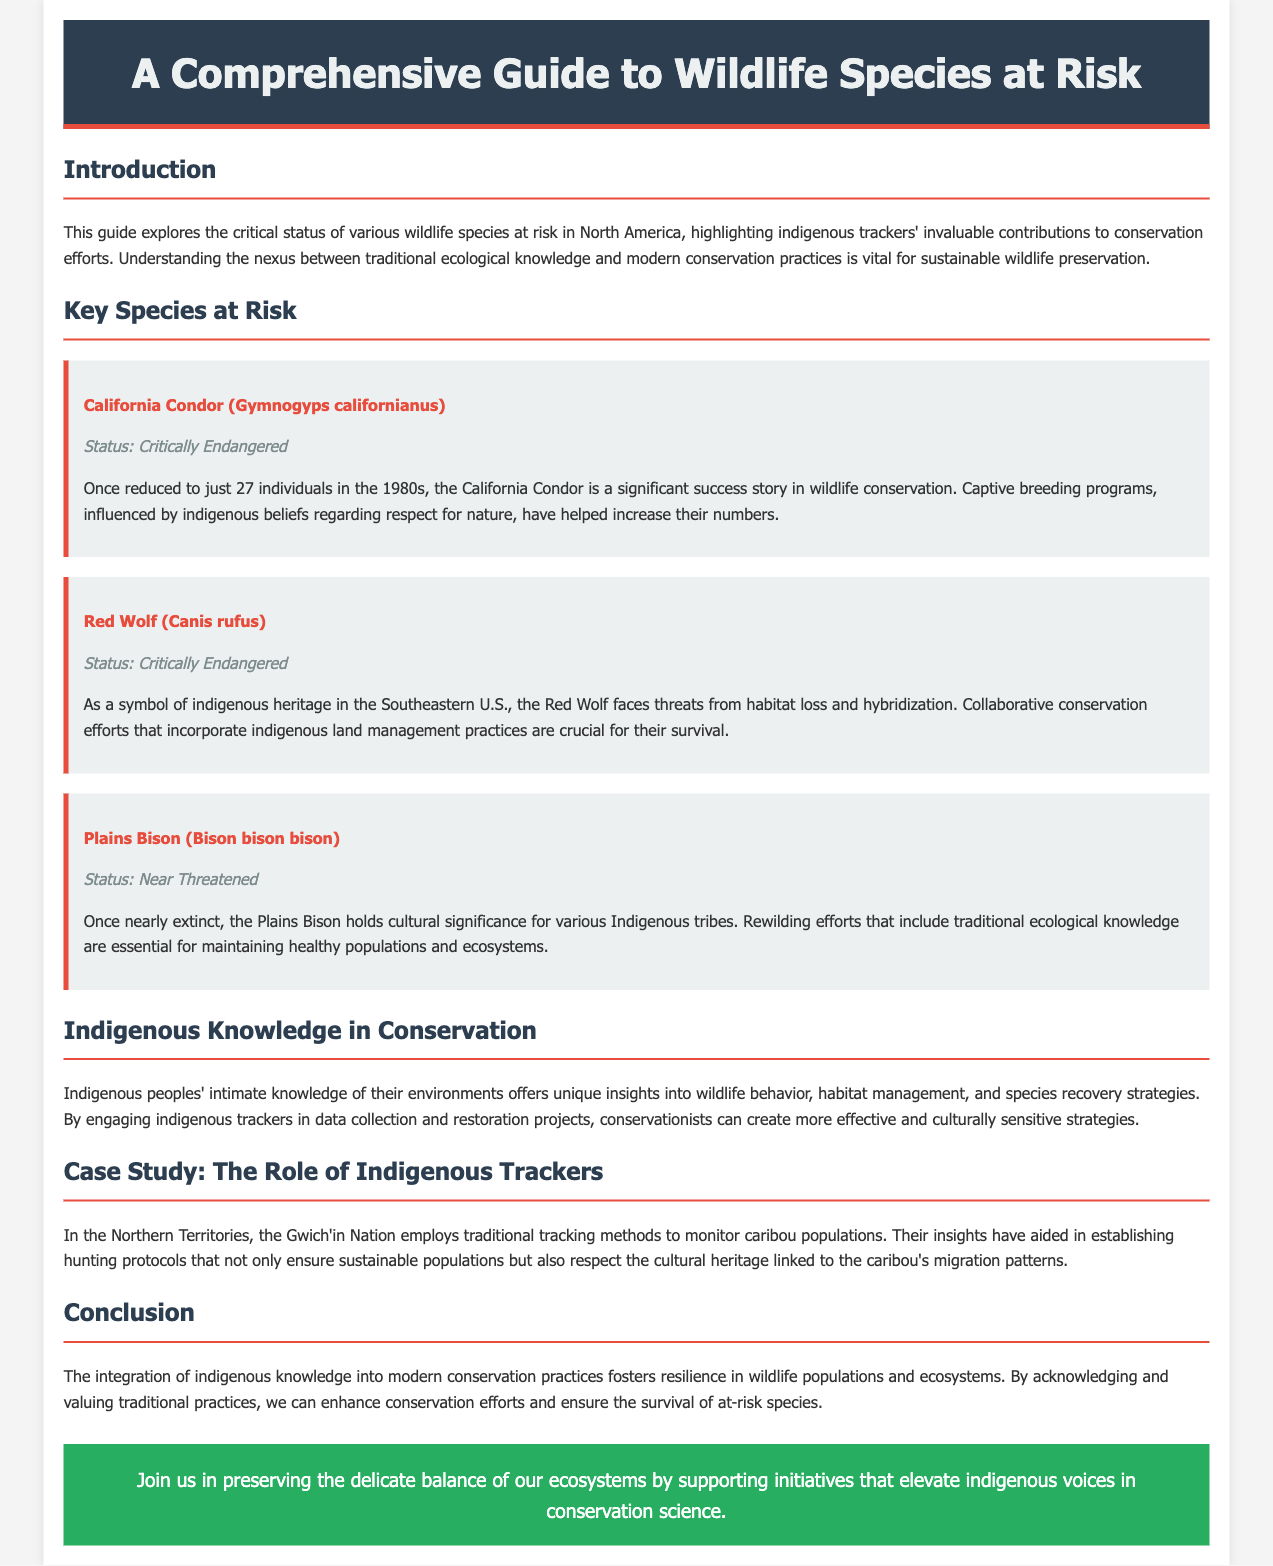What is the title of the document? The title is presented prominently at the top of the document in the header section.
Answer: A Comprehensive Guide to Wildlife Species at Risk What is the status of the California Condor? The document specifies the conservation status of each species mentioned under the Key Species at Risk section.
Answer: Critically Endangered How many individuals were left of the California Condor in the 1980s? This specific detail is provided in the description of the California Condor under Key Species at Risk.
Answer: 27 Which indigenous nation is mentioned in the case study? The document discusses the role of a specific indigenous group in wildlife tracking in the case study section.
Answer: Gwich'in Nation What is the primary focus of the guide? The guide outlines the main subject it covers in the introduction and provides insights into indigenous knowledge for conservation.
Answer: Wildlife species at risk and indigenous knowledge What role do indigenous trackers play in conservation? The document describes the contributions of indigenous trackers to conservation efforts in the relevant section.
Answer: Unique insights into wildlife behavior and habitat management What is the status of the Plains Bison? The conservation status is highlighted for each key species listed, including the Plains Bison.
Answer: Near Threatened 